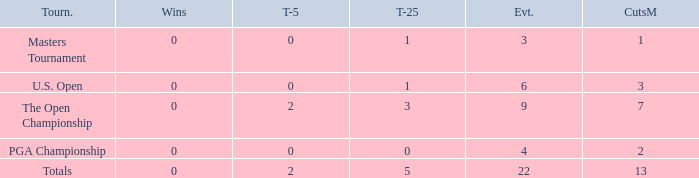What is the fewest number of top-25s for events with more than 13 cuts made? None. 